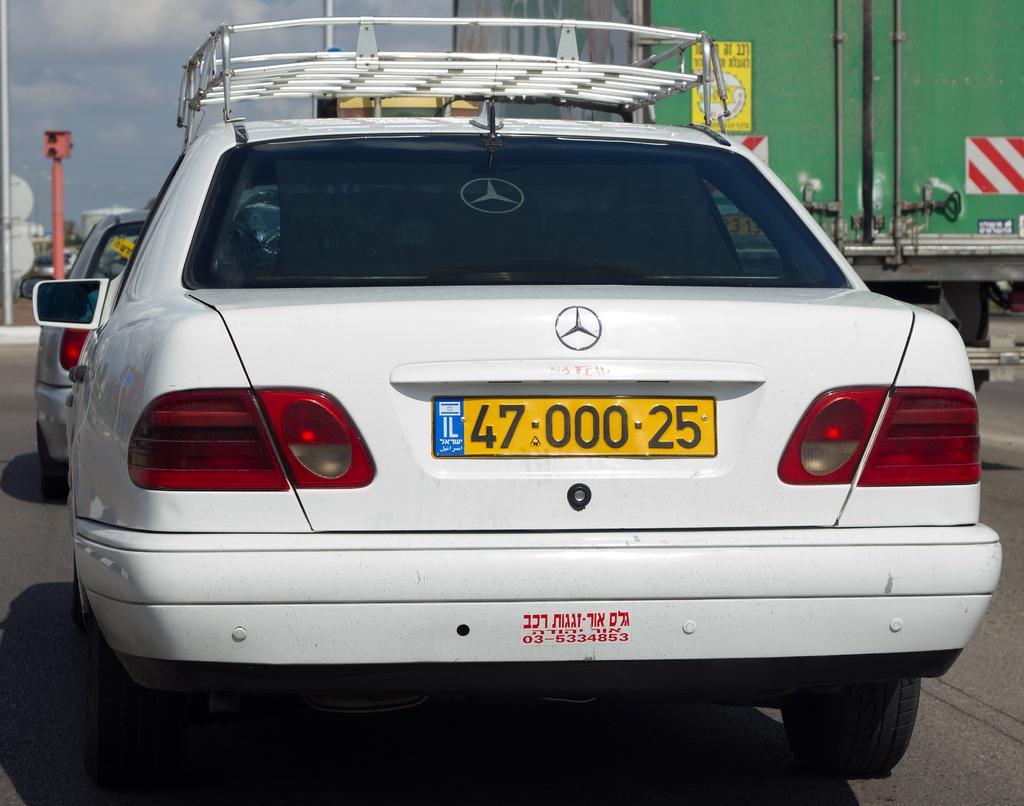Please provide a concise description of this image. In the background we can see the sky. In this picture we can see the vehicles and poles. At the bottom portion of the picture we can see the road. 